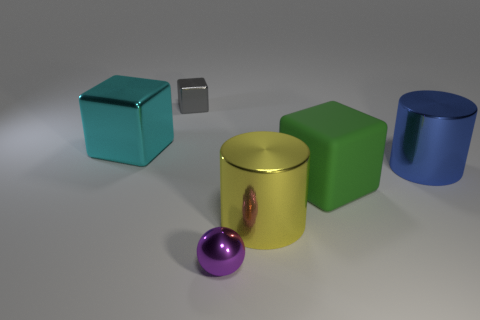Add 1 brown matte spheres. How many objects exist? 7 Subtract all spheres. How many objects are left? 5 Add 5 tiny shiny blocks. How many tiny shiny blocks are left? 6 Add 3 tiny purple metallic spheres. How many tiny purple metallic spheres exist? 4 Subtract 0 red cubes. How many objects are left? 6 Subtract all purple balls. Subtract all large green rubber blocks. How many objects are left? 4 